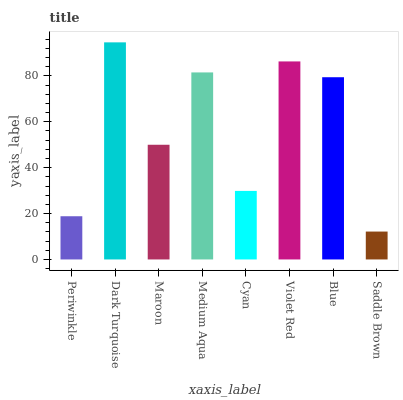Is Saddle Brown the minimum?
Answer yes or no. Yes. Is Dark Turquoise the maximum?
Answer yes or no. Yes. Is Maroon the minimum?
Answer yes or no. No. Is Maroon the maximum?
Answer yes or no. No. Is Dark Turquoise greater than Maroon?
Answer yes or no. Yes. Is Maroon less than Dark Turquoise?
Answer yes or no. Yes. Is Maroon greater than Dark Turquoise?
Answer yes or no. No. Is Dark Turquoise less than Maroon?
Answer yes or no. No. Is Blue the high median?
Answer yes or no. Yes. Is Maroon the low median?
Answer yes or no. Yes. Is Periwinkle the high median?
Answer yes or no. No. Is Dark Turquoise the low median?
Answer yes or no. No. 